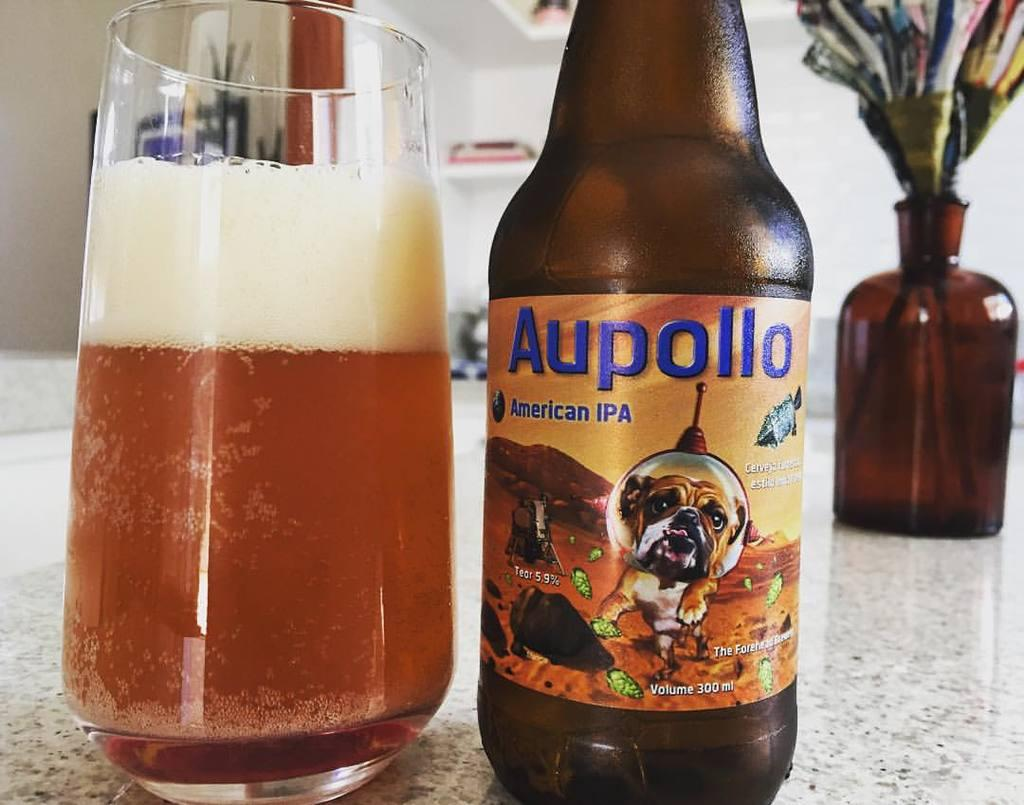What is on the table in the image? There is a glass with liquid on the table. What is located near the glass? There is a bottle to the right side of the glass. Can you describe the bottle in the right top corner of the image? There is a bottle with paper decoration in the right top corner of the image. What type of lumber is being used to support the glass in the image? There is no lumber present in the image; the glass is resting on a table. What kind of bait is visible in the image? There is no bait present in the image. 